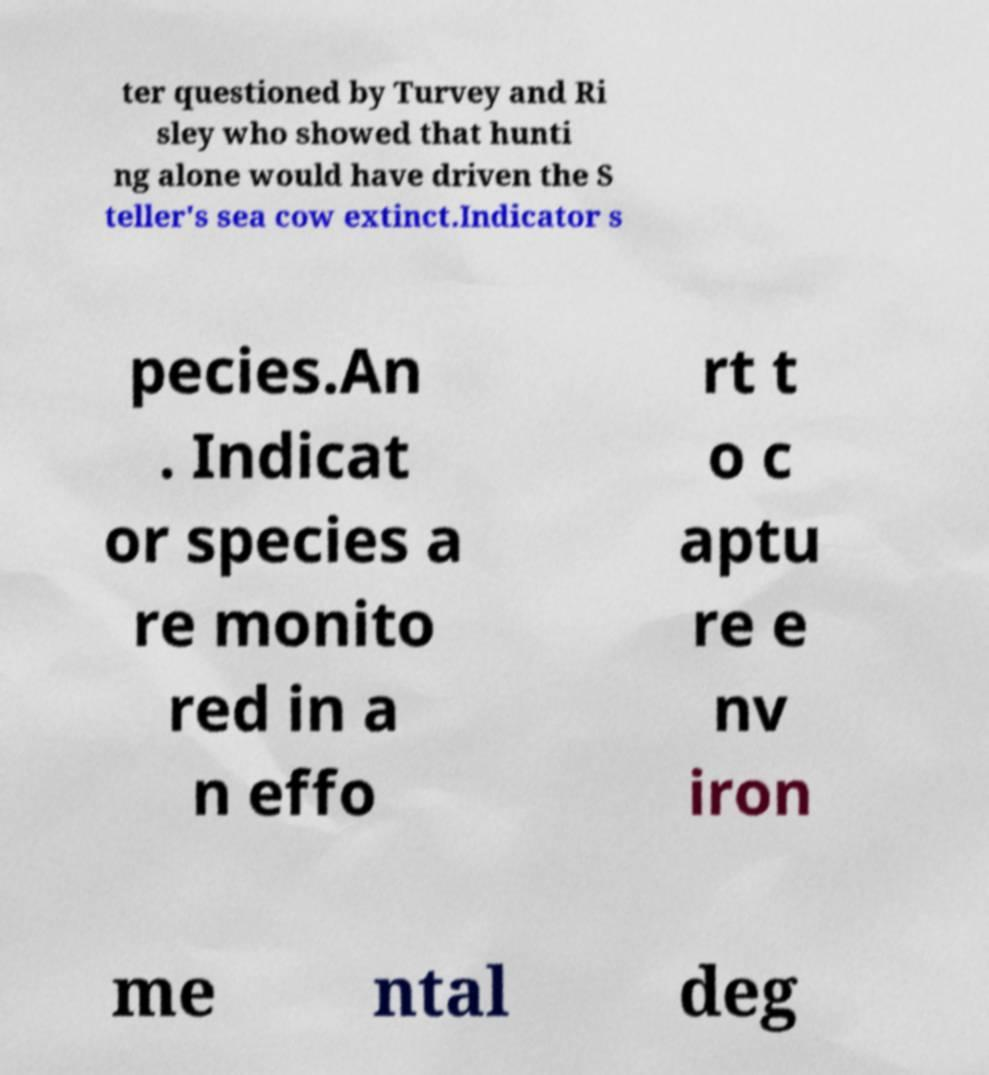Can you read and provide the text displayed in the image?This photo seems to have some interesting text. Can you extract and type it out for me? ter questioned by Turvey and Ri sley who showed that hunti ng alone would have driven the S teller's sea cow extinct.Indicator s pecies.An . Indicat or species a re monito red in a n effo rt t o c aptu re e nv iron me ntal deg 